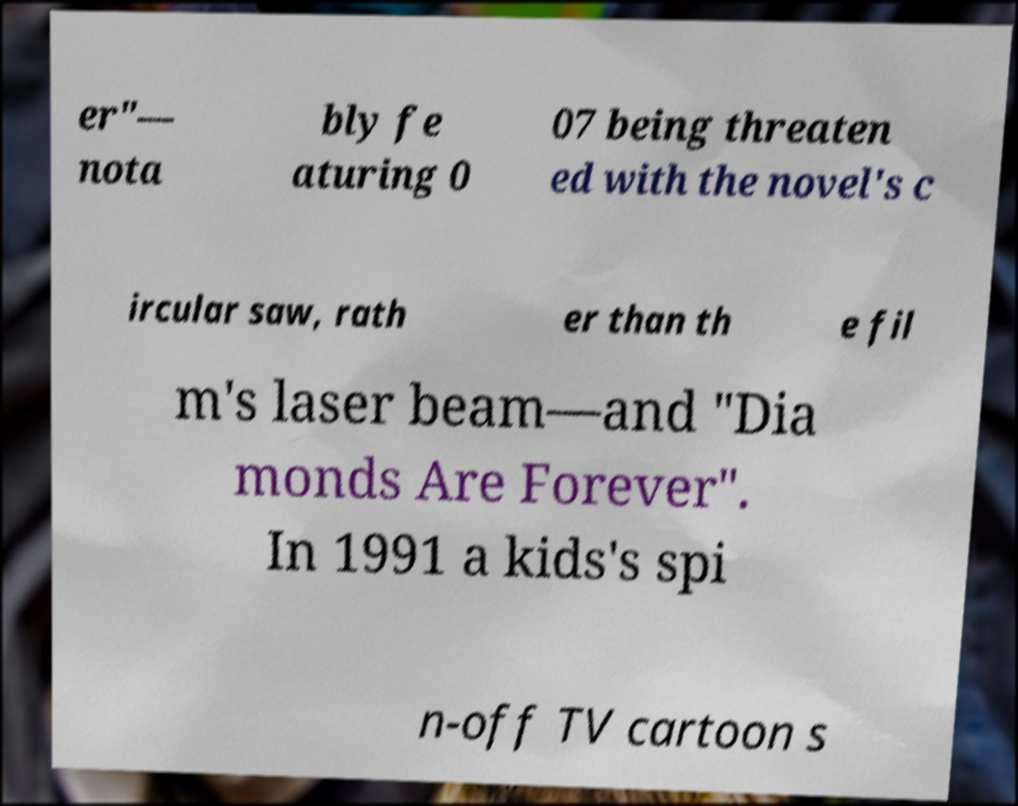For documentation purposes, I need the text within this image transcribed. Could you provide that? er"— nota bly fe aturing 0 07 being threaten ed with the novel's c ircular saw, rath er than th e fil m's laser beam—and "Dia monds Are Forever". In 1991 a kids's spi n-off TV cartoon s 